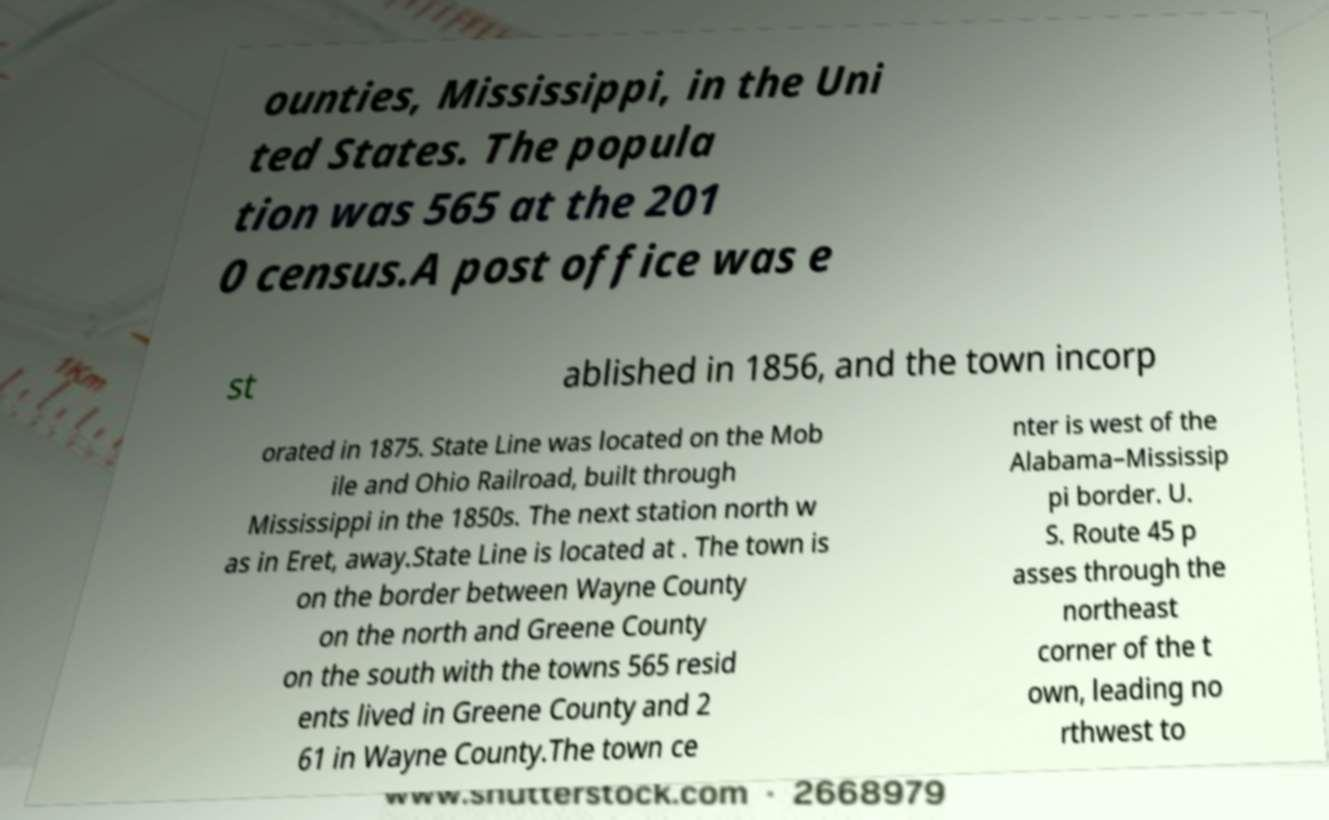Please identify and transcribe the text found in this image. ounties, Mississippi, in the Uni ted States. The popula tion was 565 at the 201 0 census.A post office was e st ablished in 1856, and the town incorp orated in 1875. State Line was located on the Mob ile and Ohio Railroad, built through Mississippi in the 1850s. The next station north w as in Eret, away.State Line is located at . The town is on the border between Wayne County on the north and Greene County on the south with the towns 565 resid ents lived in Greene County and 2 61 in Wayne County.The town ce nter is west of the Alabama–Mississip pi border. U. S. Route 45 p asses through the northeast corner of the t own, leading no rthwest to 